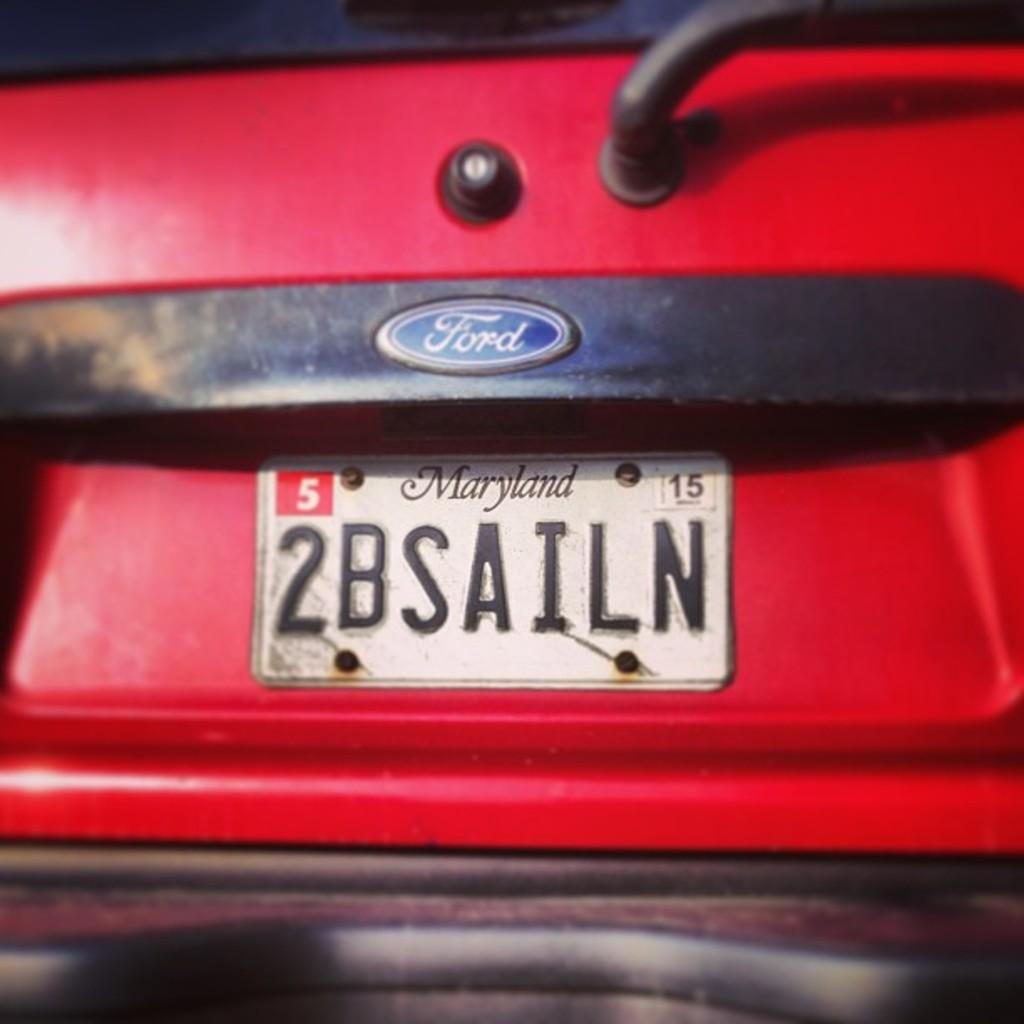<image>
Write a terse but informative summary of the picture. red ford car with an Maryland tag on the back 